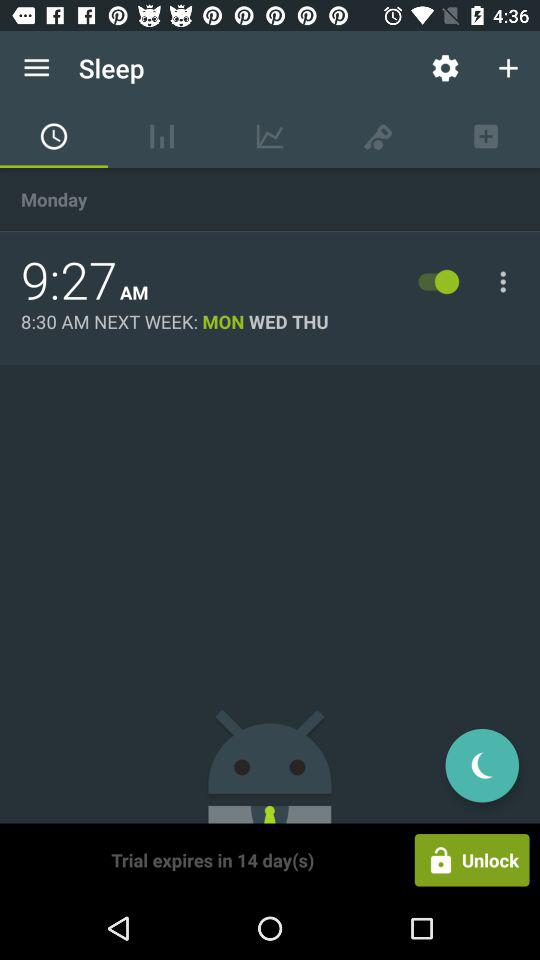For what time is the sleep alarm set? The alarm is set for 9:27 AM. 